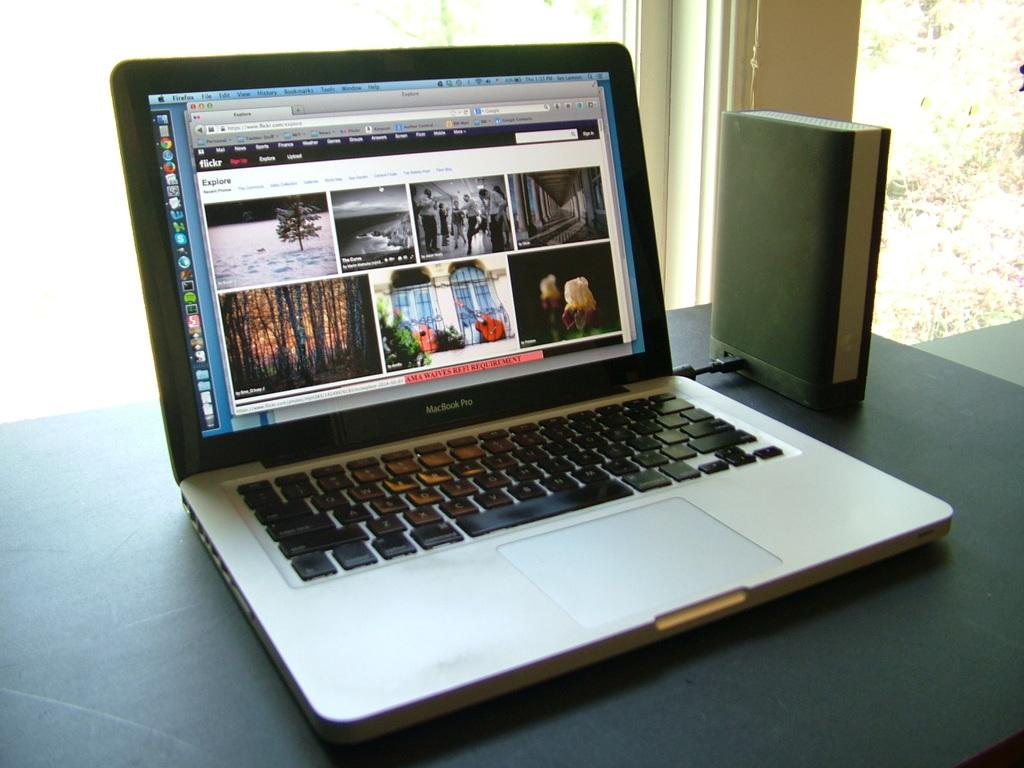<image>
Present a compact description of the photo's key features. Flickr Explore is the header of the web site on this laptop. 